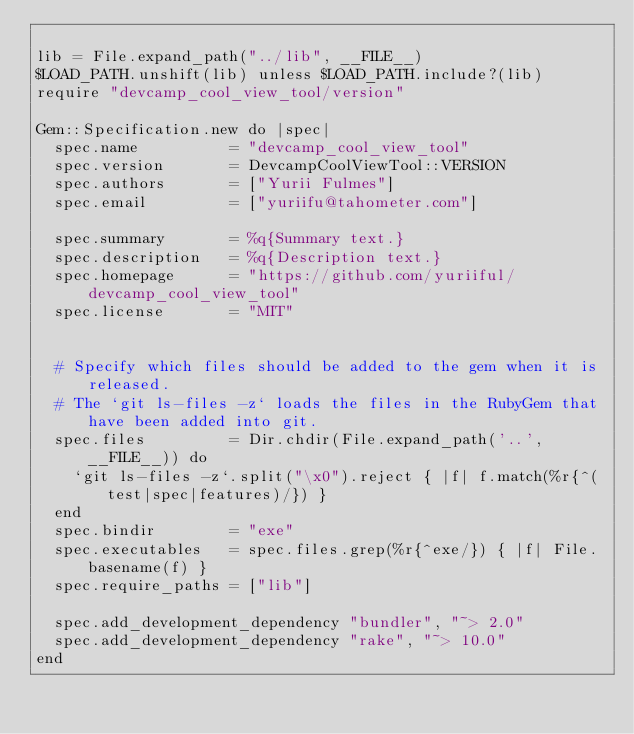Convert code to text. <code><loc_0><loc_0><loc_500><loc_500><_Ruby_>
lib = File.expand_path("../lib", __FILE__)
$LOAD_PATH.unshift(lib) unless $LOAD_PATH.include?(lib)
require "devcamp_cool_view_tool/version"

Gem::Specification.new do |spec|
  spec.name          = "devcamp_cool_view_tool"
  spec.version       = DevcampCoolViewTool::VERSION
  spec.authors       = ["Yurii Fulmes"]
  spec.email         = ["yuriifu@tahometer.com"]

  spec.summary       = %q{Summary text.}
  spec.description   = %q{Description text.}
  spec.homepage      = "https://github.com/yuriiful/devcamp_cool_view_tool"
  spec.license       = "MIT"


  # Specify which files should be added to the gem when it is released.
  # The `git ls-files -z` loads the files in the RubyGem that have been added into git.
  spec.files         = Dir.chdir(File.expand_path('..', __FILE__)) do
    `git ls-files -z`.split("\x0").reject { |f| f.match(%r{^(test|spec|features)/}) }
  end
  spec.bindir        = "exe"
  spec.executables   = spec.files.grep(%r{^exe/}) { |f| File.basename(f) }
  spec.require_paths = ["lib"]

  spec.add_development_dependency "bundler", "~> 2.0"
  spec.add_development_dependency "rake", "~> 10.0"
end
</code> 